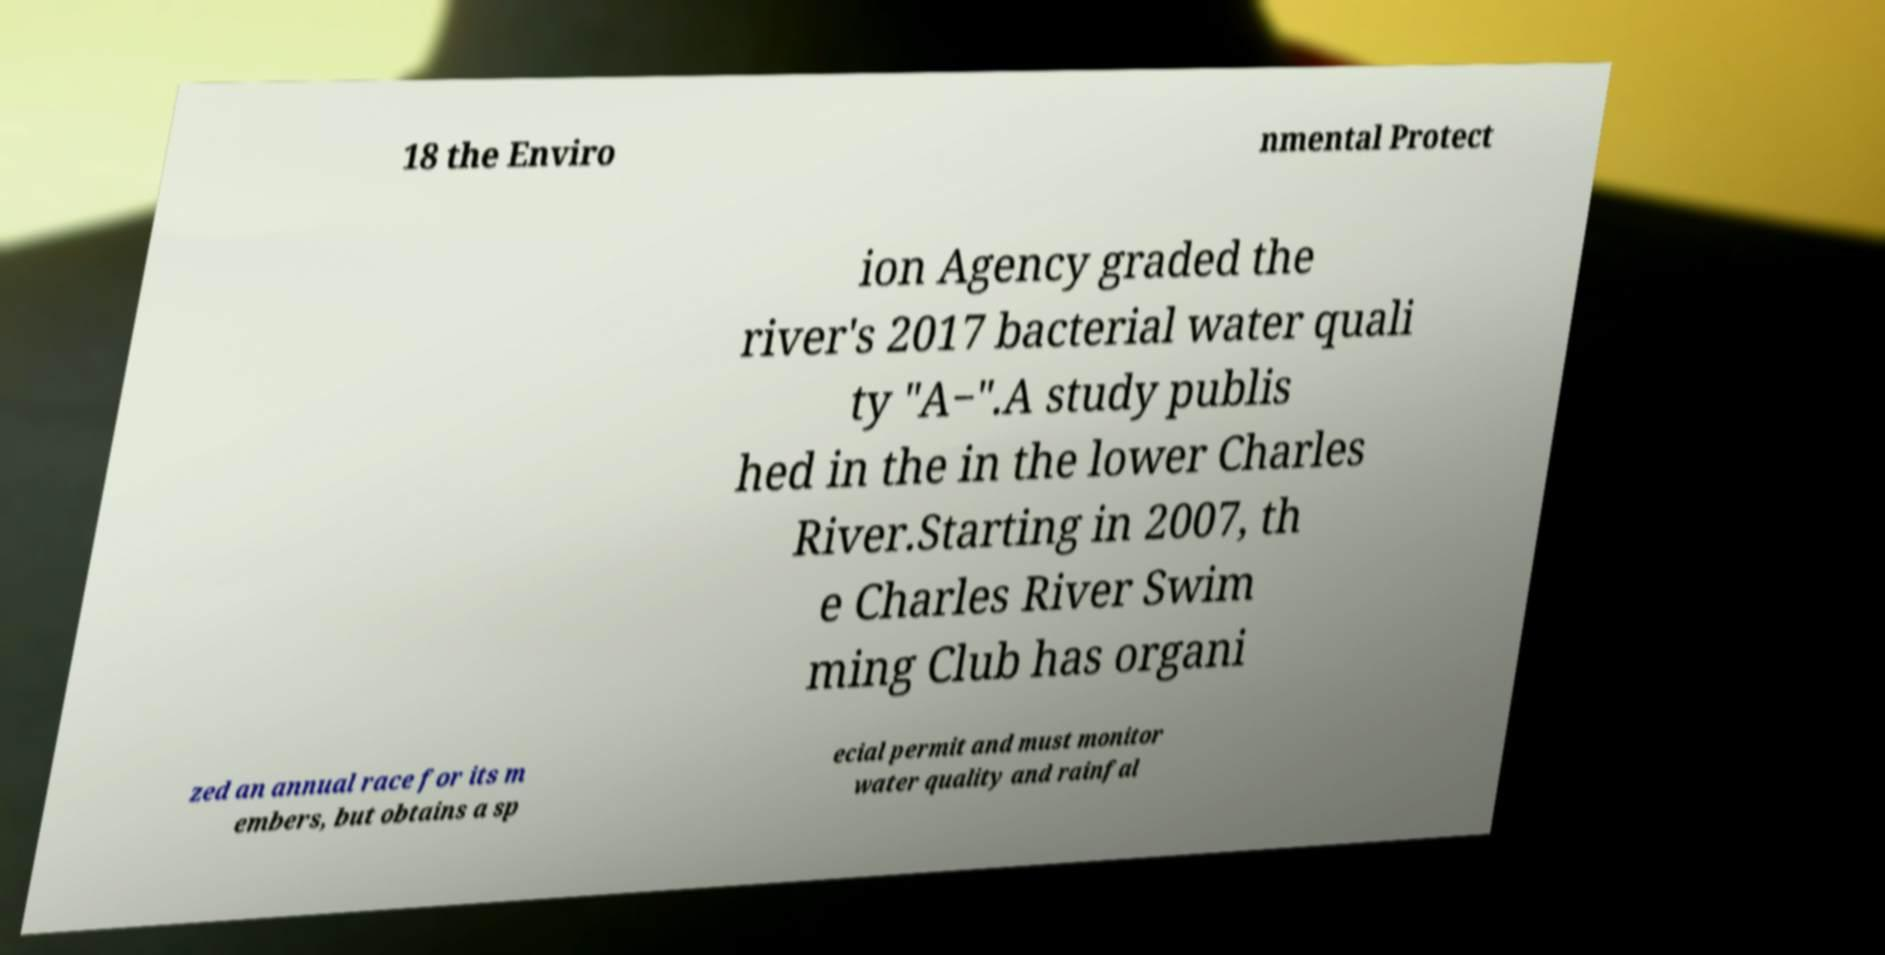Can you read and provide the text displayed in the image?This photo seems to have some interesting text. Can you extract and type it out for me? 18 the Enviro nmental Protect ion Agency graded the river's 2017 bacterial water quali ty "A−".A study publis hed in the in the lower Charles River.Starting in 2007, th e Charles River Swim ming Club has organi zed an annual race for its m embers, but obtains a sp ecial permit and must monitor water quality and rainfal 